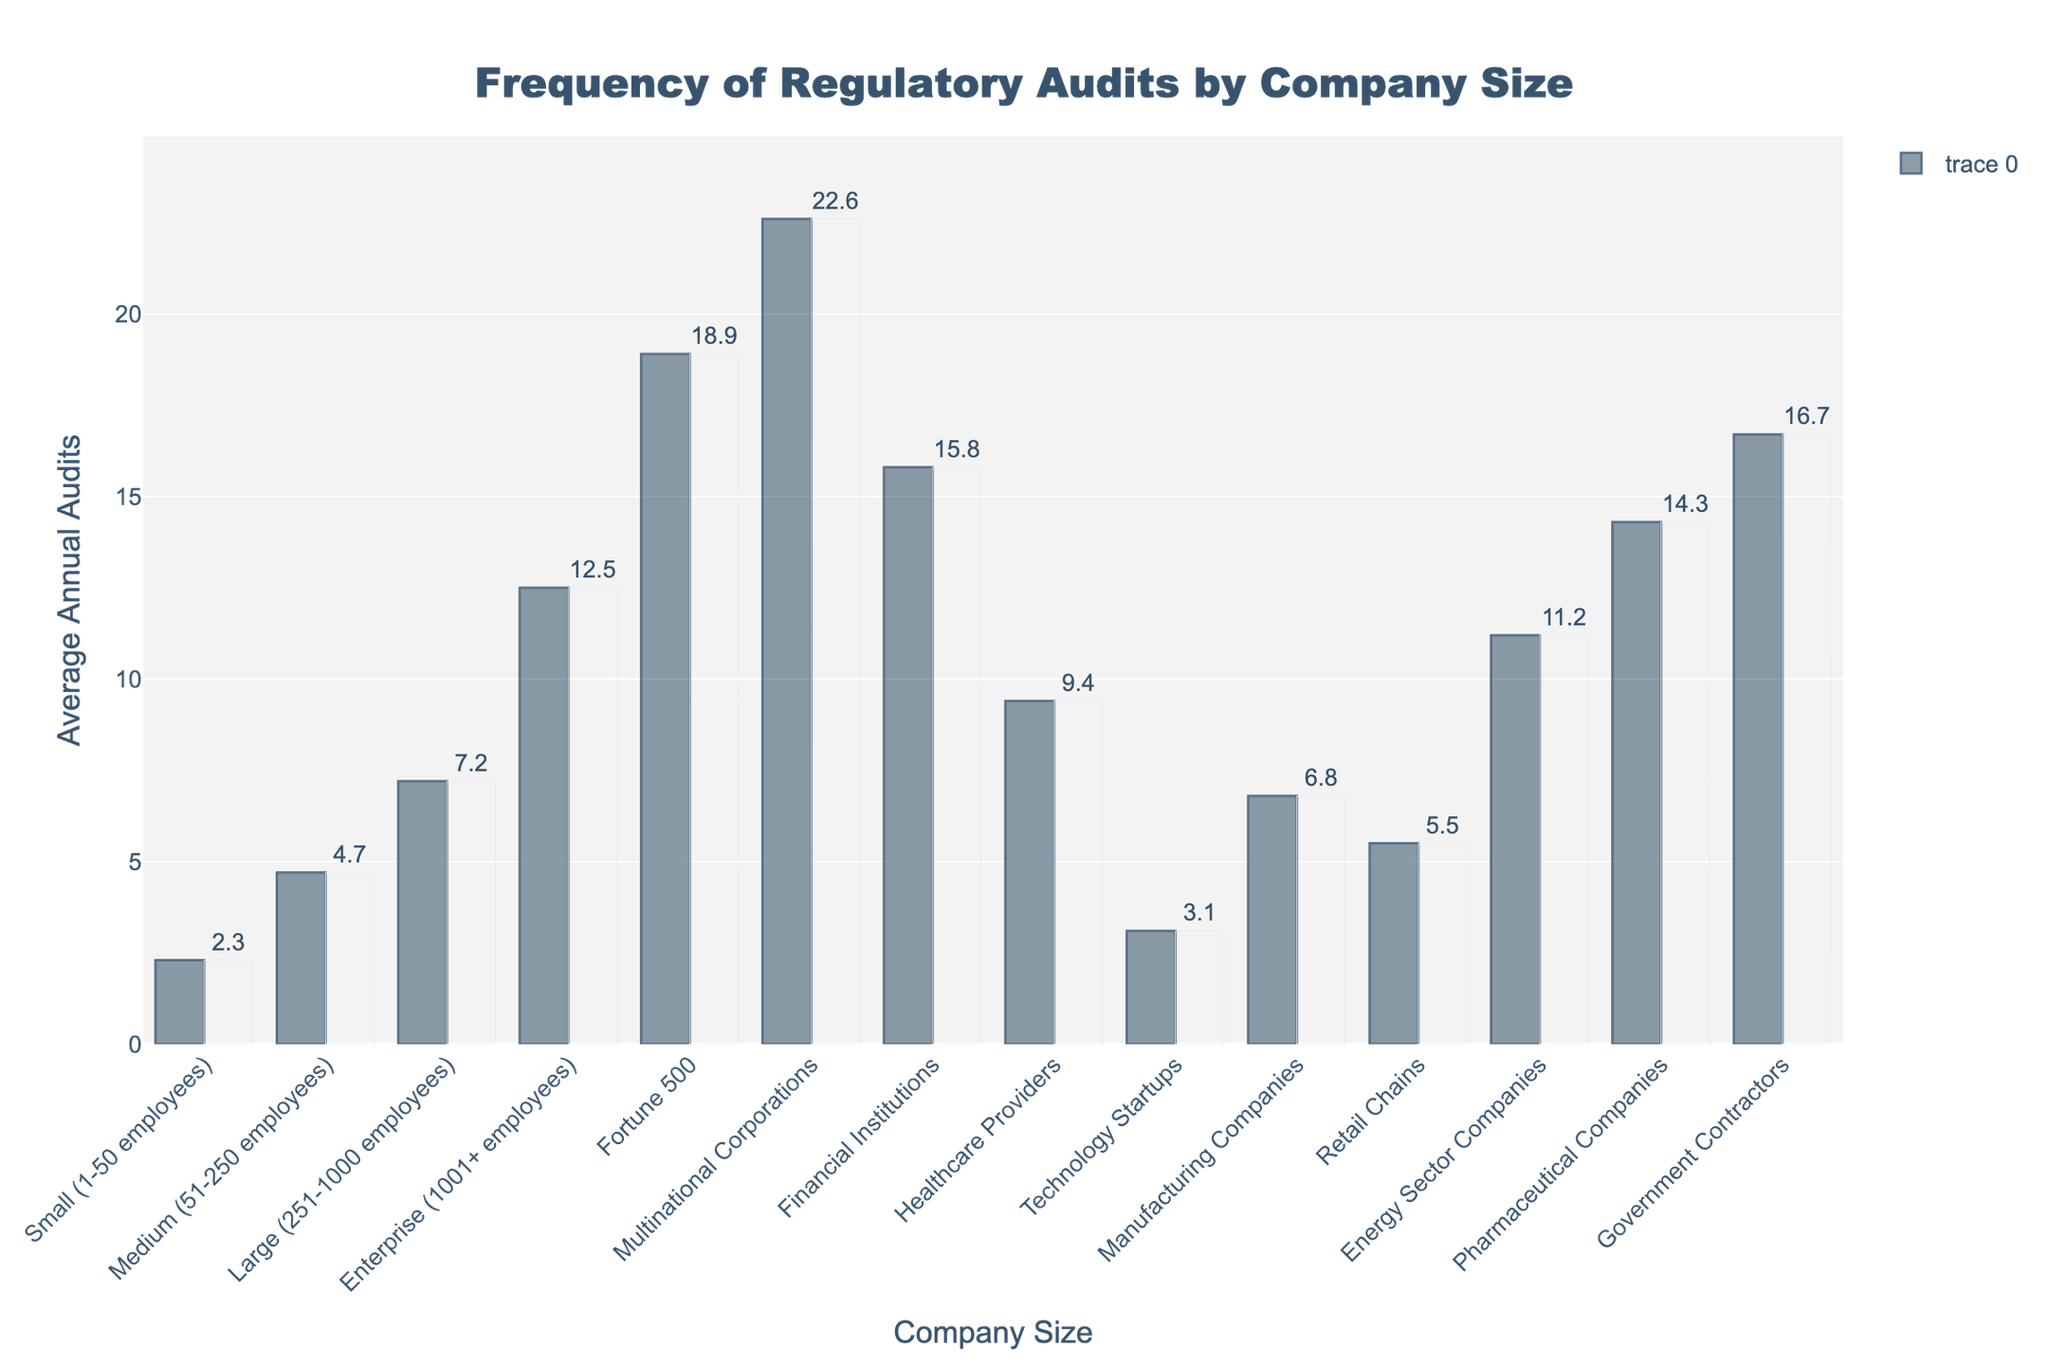What is the bar with the highest number of average annual audits? The bar representing Multinational Corporations reaches the highest point on the chart. Its label reads 22.6, indicating the highest average number of regulatory audits per year.
Answer: Multinational Corporations How many more average annual audits do Fortune 500 companies undergo compared to Technology Startups? Fortune 500 companies undergo 18.9 audits on average, while Technology Startups undergo 3.1. The difference is 18.9 - 3.1 = 15.8.
Answer: 15.8 Which type of company undergoes fewer average annual audits, Healthcare Providers or Manufacturing Companies? The bar for Healthcare Providers indicates 9.4 audits, while Manufacturing Companies indicate 6.8. Since 6.8 is less than 9.4, Manufacturing Companies undergo fewer audits.
Answer: Manufacturing Companies How do the average annual audits for Financial Institutions compare to those for Enterprise companies? The bar for Financial Institutions is at 15.8, whereas Enterprise companies are at 12.5. Since 15.8 is greater than 12.5, Financial Institutions have more audits on average.
Answer: Financial Institutions What is the combined average annual audits for Government Contractors and Pharmaceutical Companies? Government Contractors have 16.7 annual audits and Pharmaceutical Companies have 14.3. Summing these yields 16.7 + 14.3 = 31.
Answer: 31 